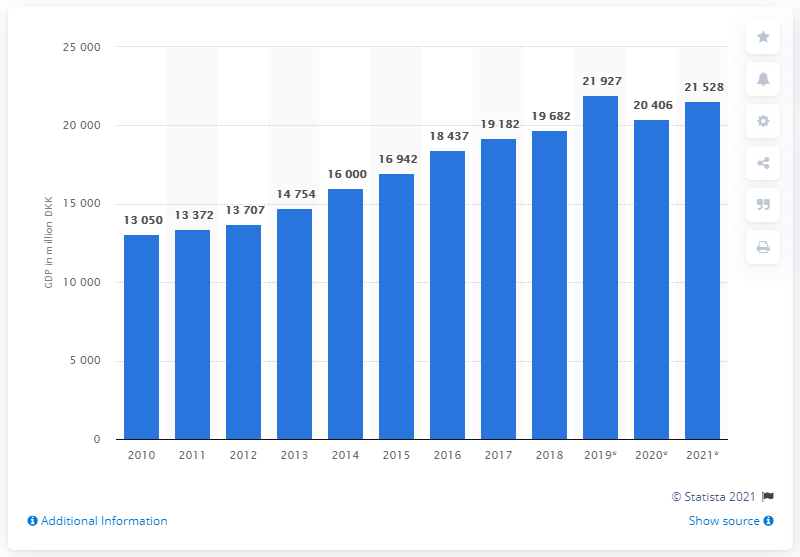Highlight a few significant elements in this photo. The forecast for the GDP of the Faroe Islands in 2021 is expected to be 21,528. The Gross Domestic Product (GDP) of the Faroe Islands in the year 2018 was approximately 19,682. 